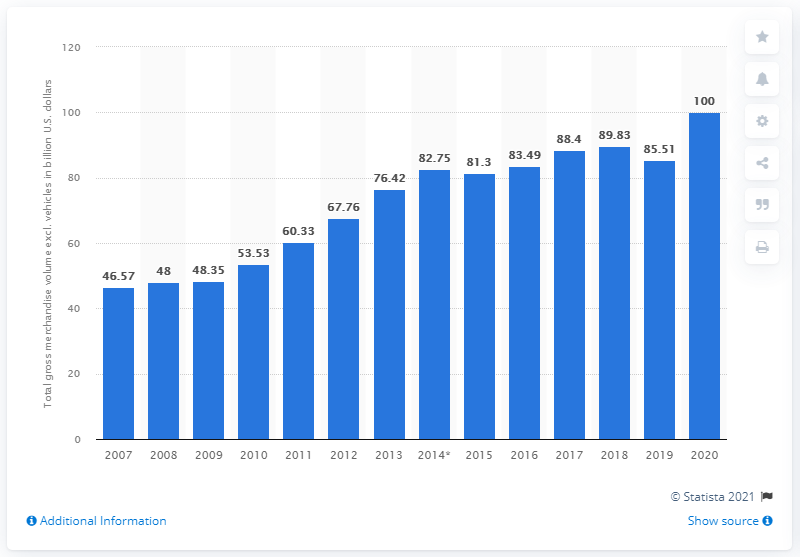Point out several critical features in this image. In the most recent fiscal year, eBay's gross merchandise volume was $100 billion. In the previous year, eBay's gross merchandise volume was 85.51. 